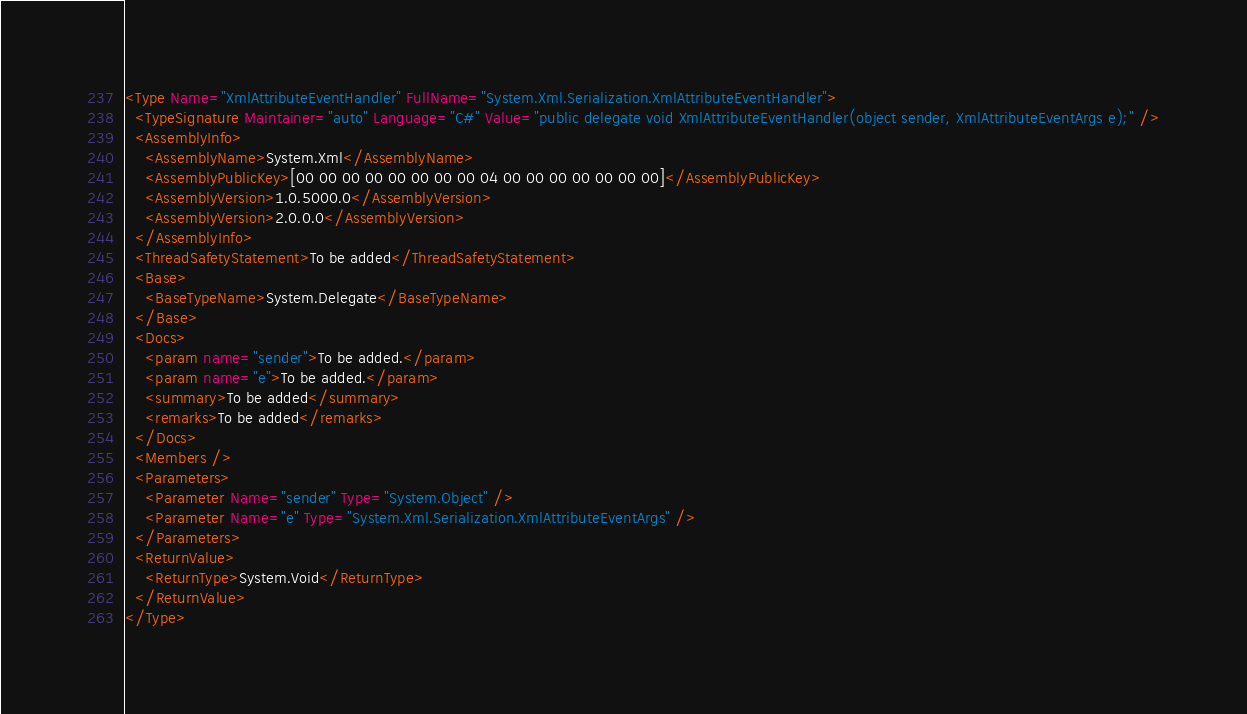<code> <loc_0><loc_0><loc_500><loc_500><_XML_><Type Name="XmlAttributeEventHandler" FullName="System.Xml.Serialization.XmlAttributeEventHandler">
  <TypeSignature Maintainer="auto" Language="C#" Value="public delegate void XmlAttributeEventHandler(object sender, XmlAttributeEventArgs e);" />
  <AssemblyInfo>
    <AssemblyName>System.Xml</AssemblyName>
    <AssemblyPublicKey>[00 00 00 00 00 00 00 00 04 00 00 00 00 00 00 00]</AssemblyPublicKey>
    <AssemblyVersion>1.0.5000.0</AssemblyVersion>
    <AssemblyVersion>2.0.0.0</AssemblyVersion>
  </AssemblyInfo>
  <ThreadSafetyStatement>To be added</ThreadSafetyStatement>
  <Base>
    <BaseTypeName>System.Delegate</BaseTypeName>
  </Base>
  <Docs>
    <param name="sender">To be added.</param>
    <param name="e">To be added.</param>
    <summary>To be added</summary>
    <remarks>To be added</remarks>
  </Docs>
  <Members />
  <Parameters>
    <Parameter Name="sender" Type="System.Object" />
    <Parameter Name="e" Type="System.Xml.Serialization.XmlAttributeEventArgs" />
  </Parameters>
  <ReturnValue>
    <ReturnType>System.Void</ReturnType>
  </ReturnValue>
</Type>
</code> 